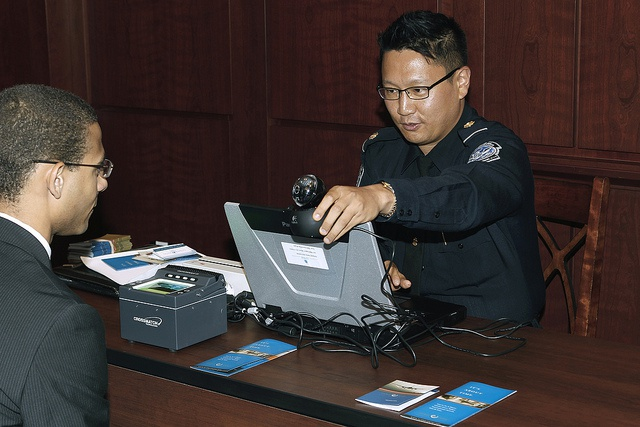Describe the objects in this image and their specific colors. I can see people in black, tan, and gray tones, people in black, gray, purple, and tan tones, laptop in black, darkgray, gray, and lavender tones, chair in black, maroon, and brown tones, and mouse in black and purple tones in this image. 